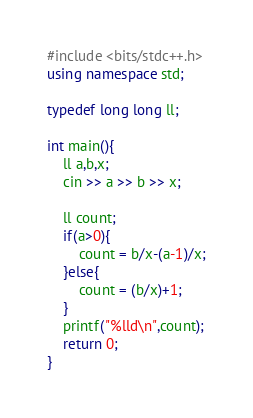Convert code to text. <code><loc_0><loc_0><loc_500><loc_500><_C++_>#include <bits/stdc++.h>
using namespace std;

typedef long long ll;

int main(){
    ll a,b,x;
    cin >> a >> b >> x;

    ll count;    
    if(a>0){
        count = b/x-(a-1)/x;
    }else{
        count = (b/x)+1;
    }
    printf("%lld\n",count);
    return 0;
}
</code> 